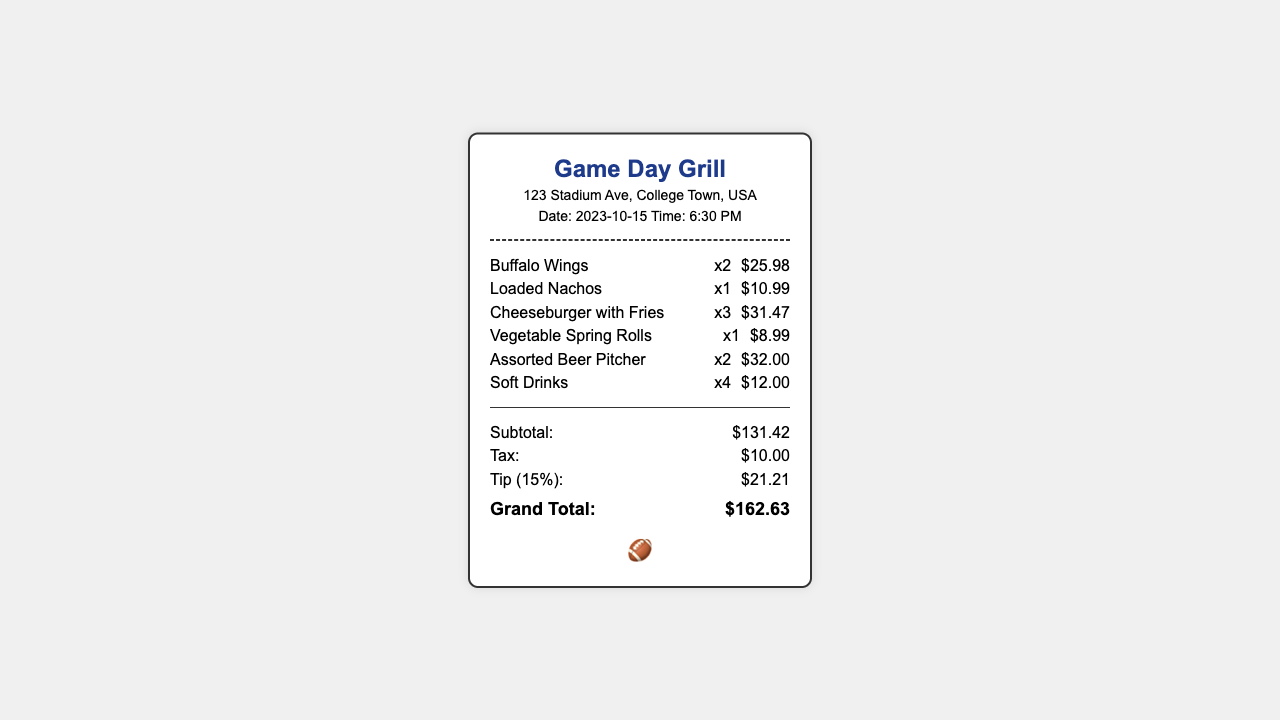What is the restaurant name? The restaurant name is prominently displayed at the top of the receipt.
Answer: Game Day Grill What is the subtotal amount? The subtotal is listed under the totals section of the receipt.
Answer: $131.42 How many Buffalo Wings were ordered? The quantity of Buffalo Wings is shown next to the item name on the receipt.
Answer: x2 What is the tax amount? The tax amount is included in the totals section of the receipt.
Answer: $10.00 What percentage was used for the tip calculation? The tip percentage is specified before the tip amount in the totals section.
Answer: 15% What is the grand total amount? The grand total is the final amount displayed on the receipt.
Answer: $162.63 How many Soft Drinks were ordered? The quantity of Soft Drinks appears next to the item name on the receipt.
Answer: x4 What was the price of the Loaded Nachos? The price of each item is shown in the order section next to the item name.
Answer: $10.99 What time was the order placed? The time of the order is listed along with the date at the top of the receipt.
Answer: 6:30 PM 